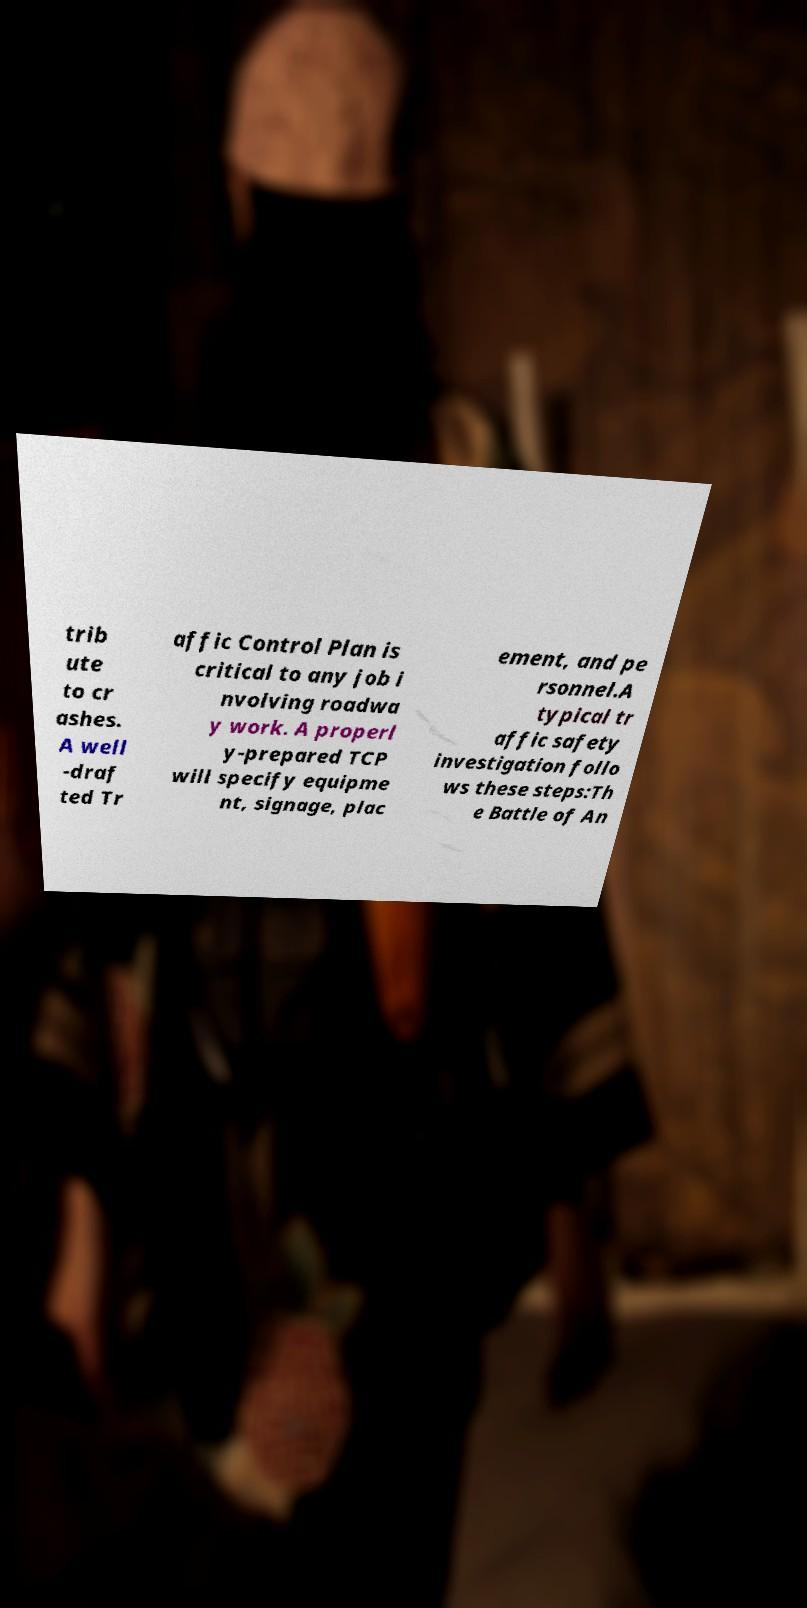Could you extract and type out the text from this image? trib ute to cr ashes. A well -draf ted Tr affic Control Plan is critical to any job i nvolving roadwa y work. A properl y-prepared TCP will specify equipme nt, signage, plac ement, and pe rsonnel.A typical tr affic safety investigation follo ws these steps:Th e Battle of An 